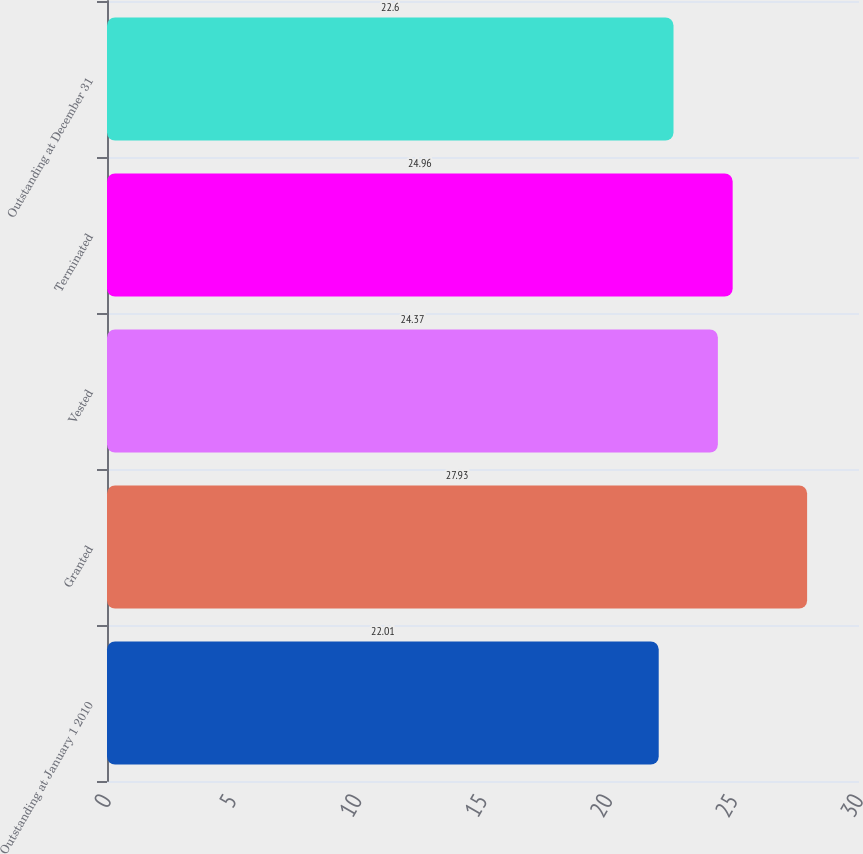<chart> <loc_0><loc_0><loc_500><loc_500><bar_chart><fcel>Outstanding at January 1 2010<fcel>Granted<fcel>Vested<fcel>Terminated<fcel>Outstanding at December 31<nl><fcel>22.01<fcel>27.93<fcel>24.37<fcel>24.96<fcel>22.6<nl></chart> 